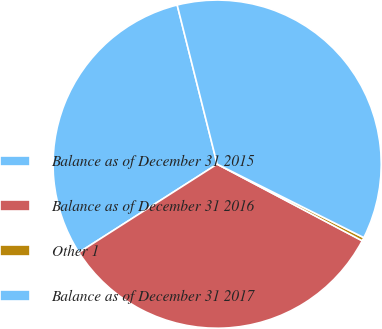<chart> <loc_0><loc_0><loc_500><loc_500><pie_chart><fcel>Balance as of December 31 2015<fcel>Balance as of December 31 2016<fcel>Other 1<fcel>Balance as of December 31 2017<nl><fcel>30.13%<fcel>33.22%<fcel>0.34%<fcel>36.31%<nl></chart> 